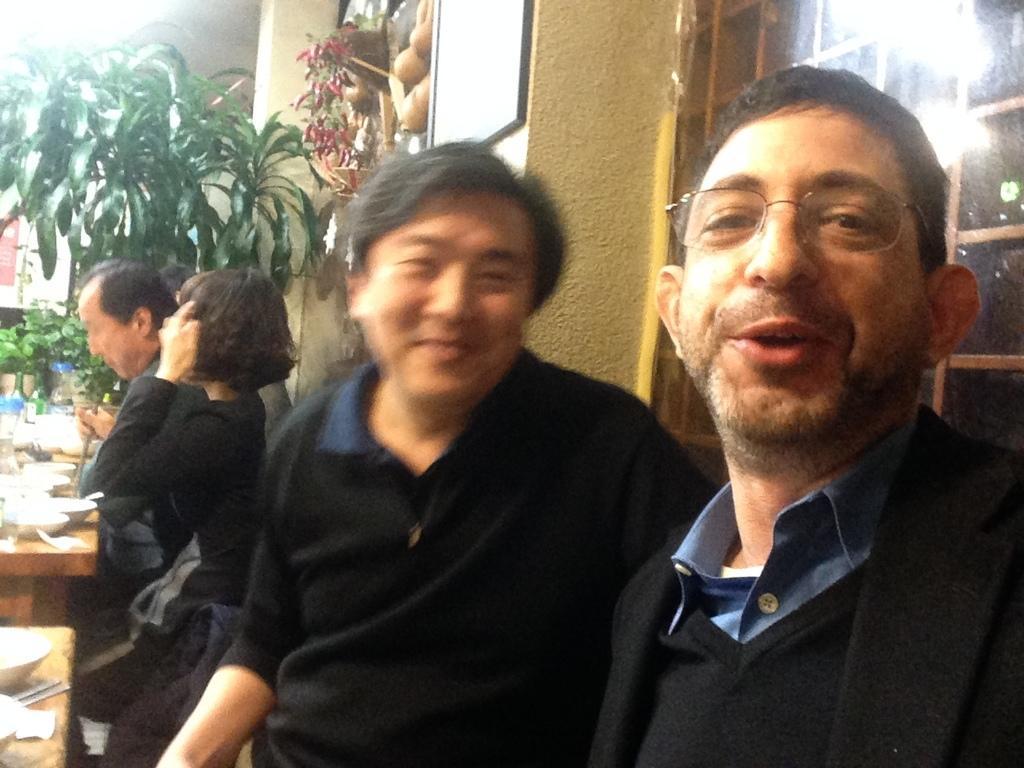In one or two sentences, can you explain what this image depicts? This image consists of four persons. All are wearing black colored dresses. On the left, there are tables on which we can see the bowls and spoons. It looks like a restaurant. In the background, we can see the plants along with a wall. On the right, it looks like a window. 